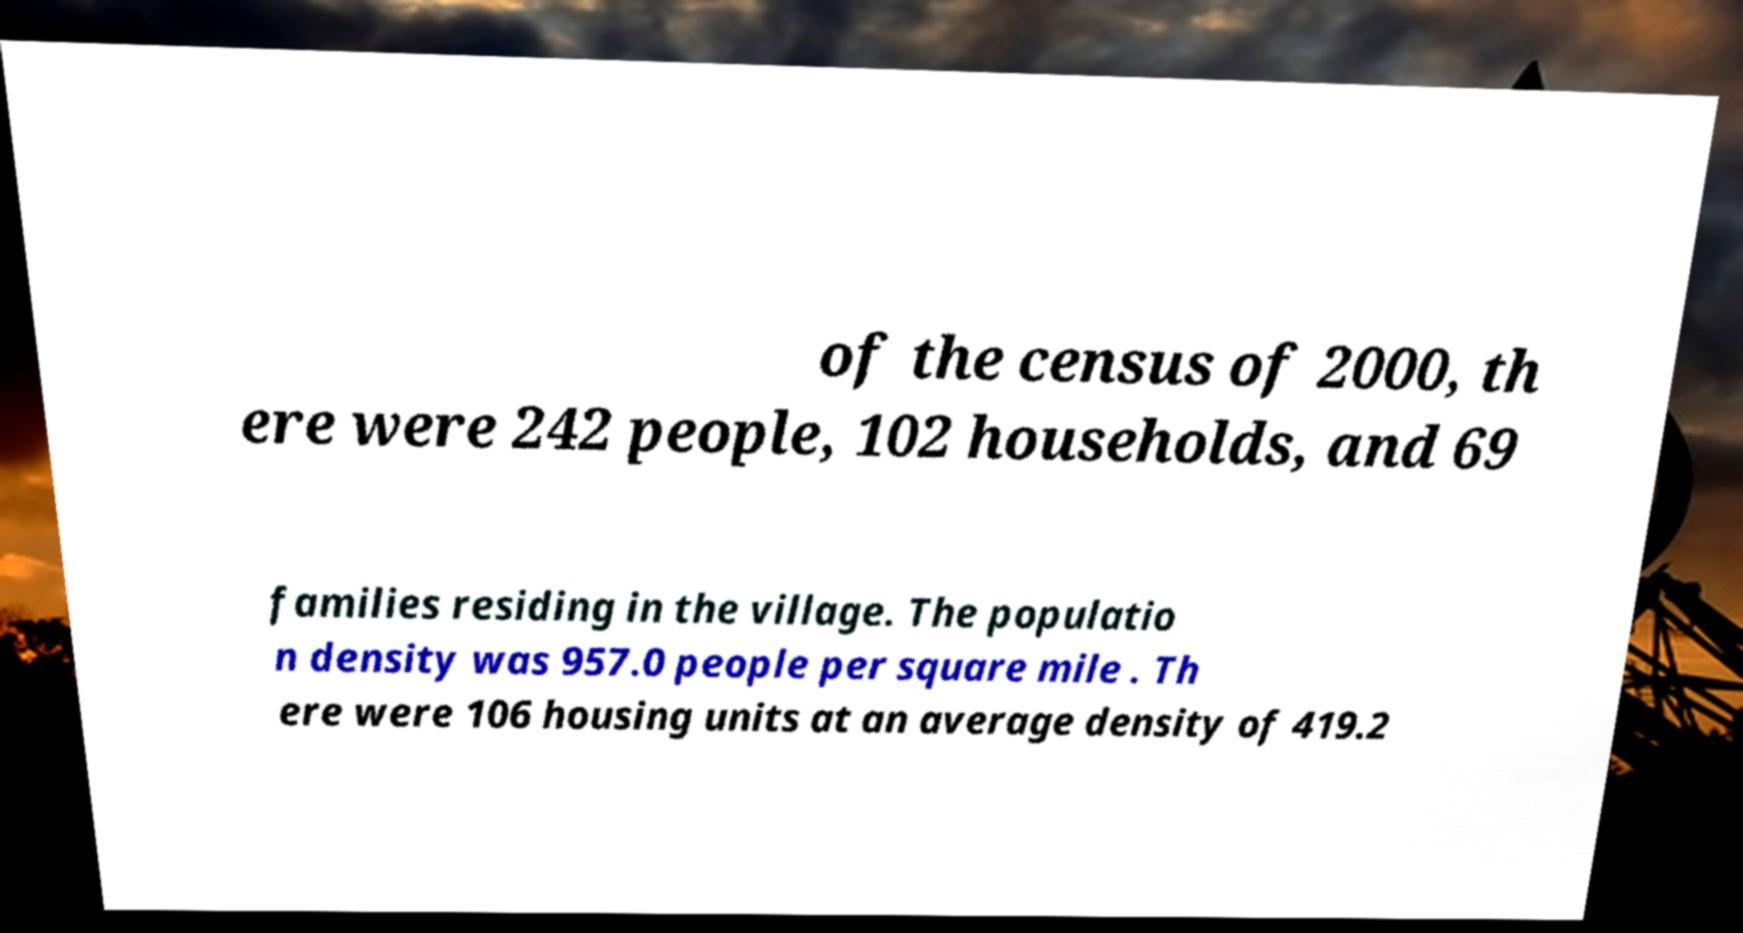What messages or text are displayed in this image? I need them in a readable, typed format. of the census of 2000, th ere were 242 people, 102 households, and 69 families residing in the village. The populatio n density was 957.0 people per square mile . Th ere were 106 housing units at an average density of 419.2 